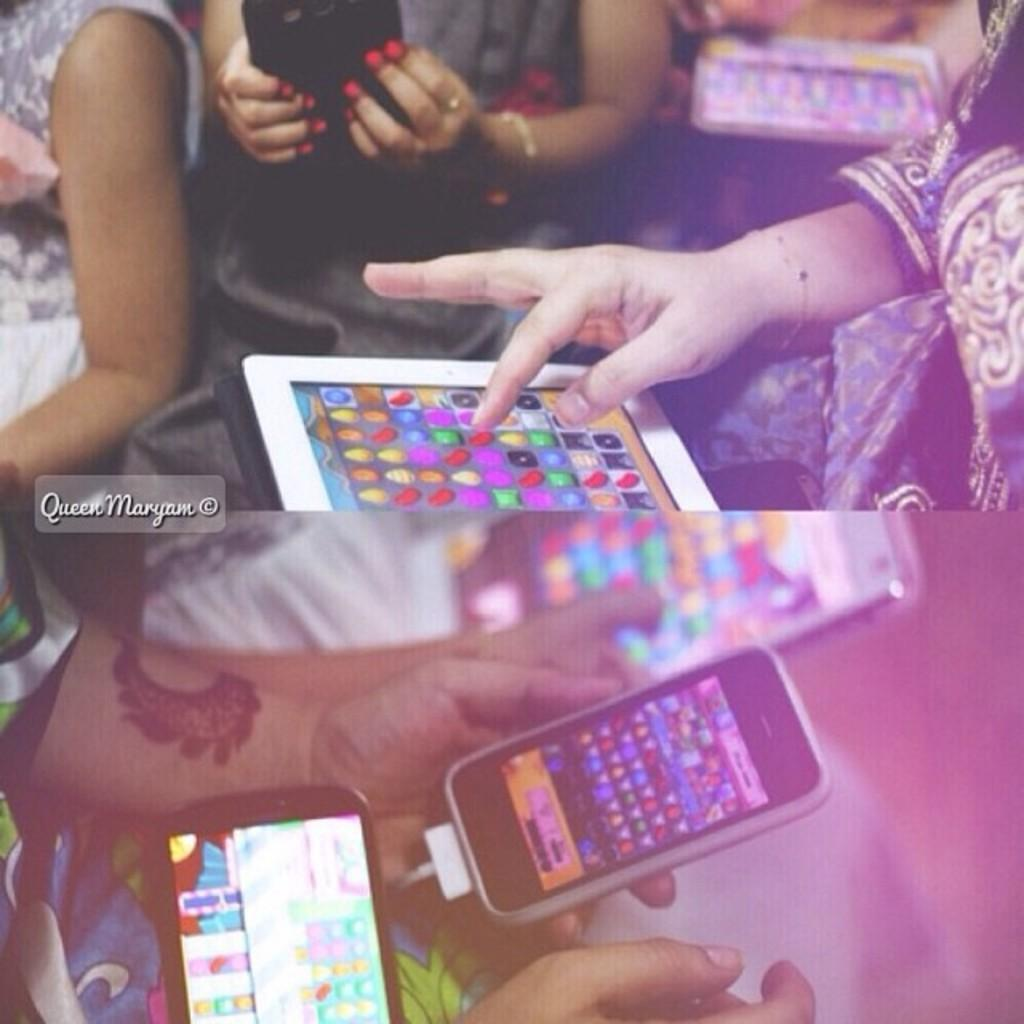What is the composition of the image? The image is a collage of two pictures. What are the people in the image doing? The people in the image are holding phones. What can be seen on the screens of the phones? There are things displayed on the screens of the phones. What is the opinion of the yak about the son in the image? There is no yak or son present in the image, so it is not possible to determine their opinions. 